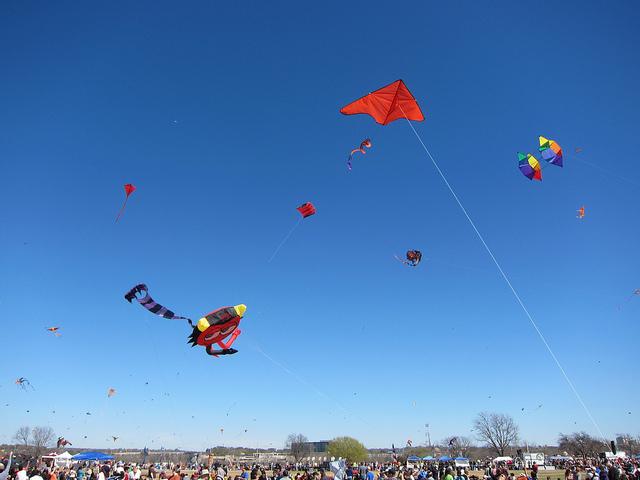What is the weather like?
Give a very brief answer. Windy. What is in the air?
Be succinct. Kites. How many kites in sky?
Short answer required. Many. What animal is the pink kite?
Quick response, please. Cat. 